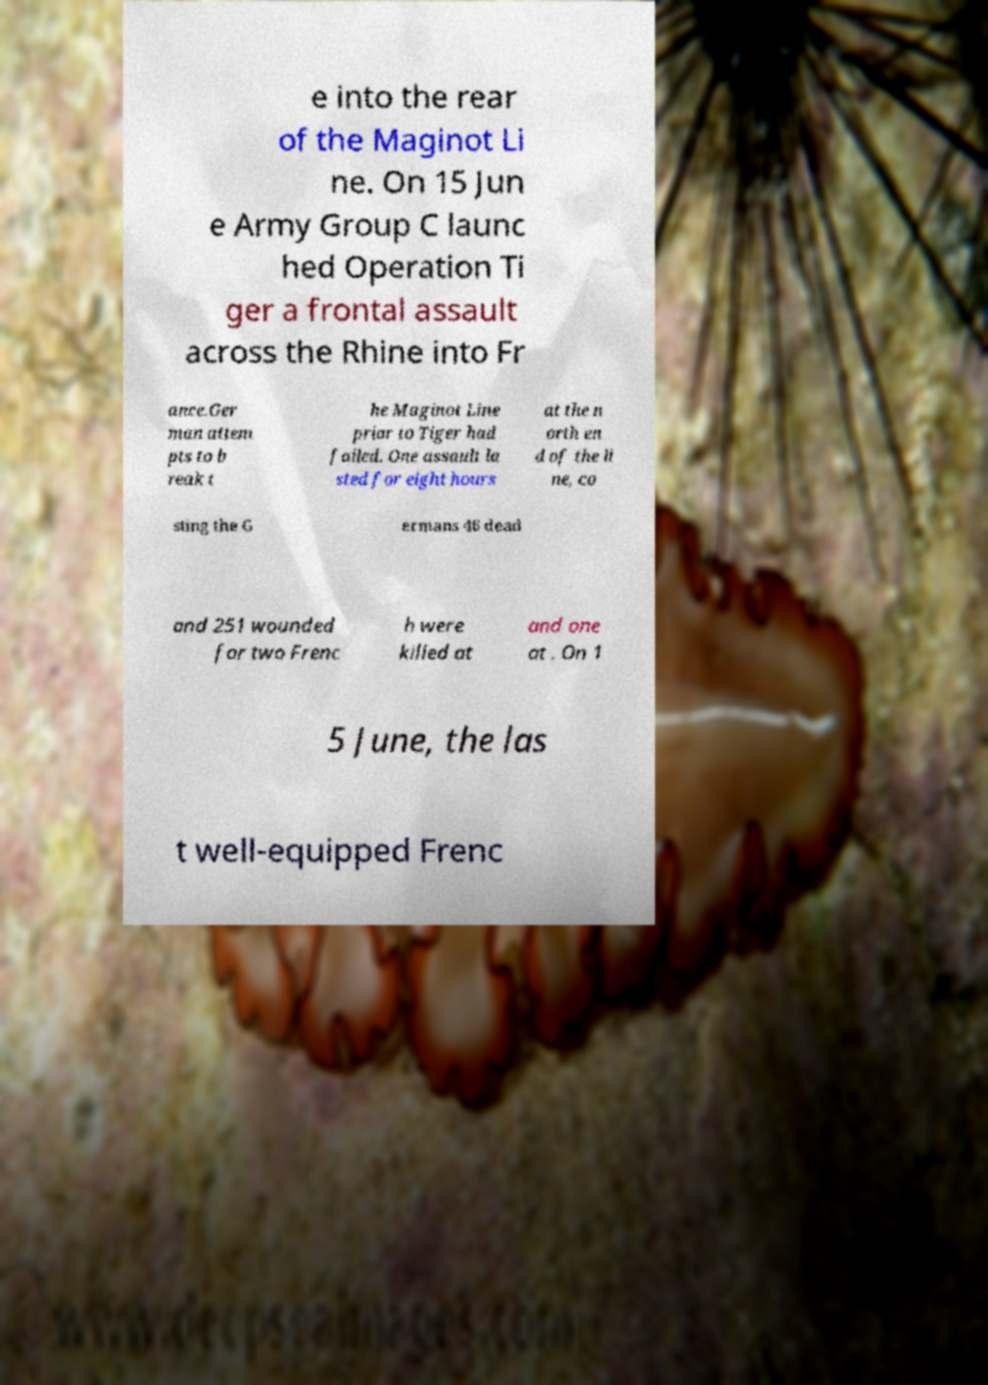Could you assist in decoding the text presented in this image and type it out clearly? e into the rear of the Maginot Li ne. On 15 Jun e Army Group C launc hed Operation Ti ger a frontal assault across the Rhine into Fr ance.Ger man attem pts to b reak t he Maginot Line prior to Tiger had failed. One assault la sted for eight hours at the n orth en d of the li ne, co sting the G ermans 46 dead and 251 wounded for two Frenc h were killed at and one at . On 1 5 June, the las t well-equipped Frenc 